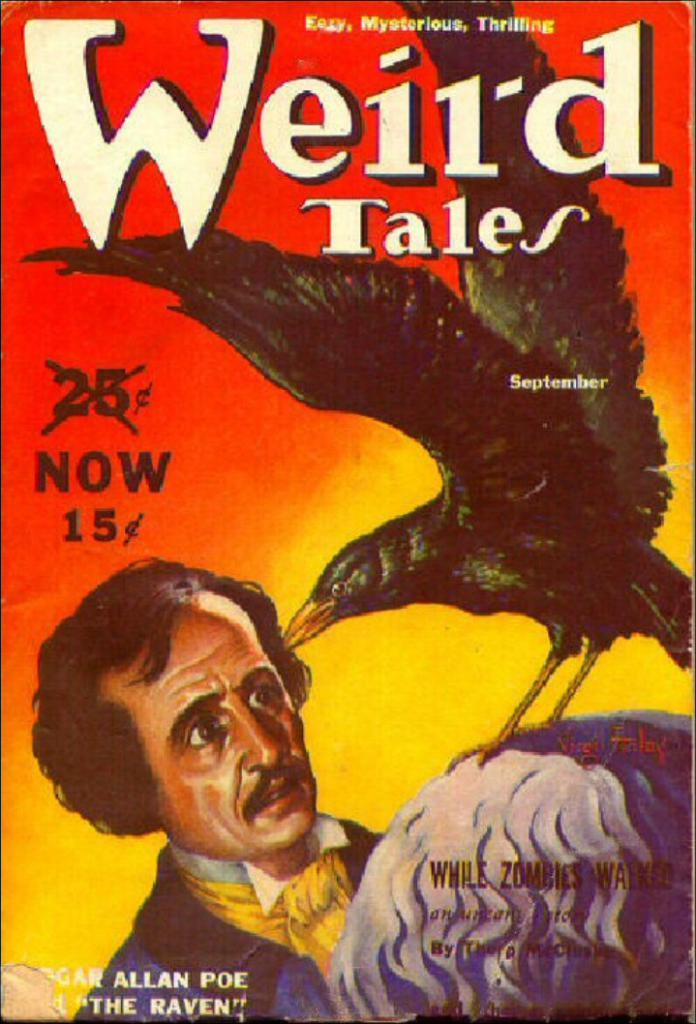<image>
Offer a succinct explanation of the picture presented. A vintage copy o Weird Tales magazine including The Raven by Poe. 